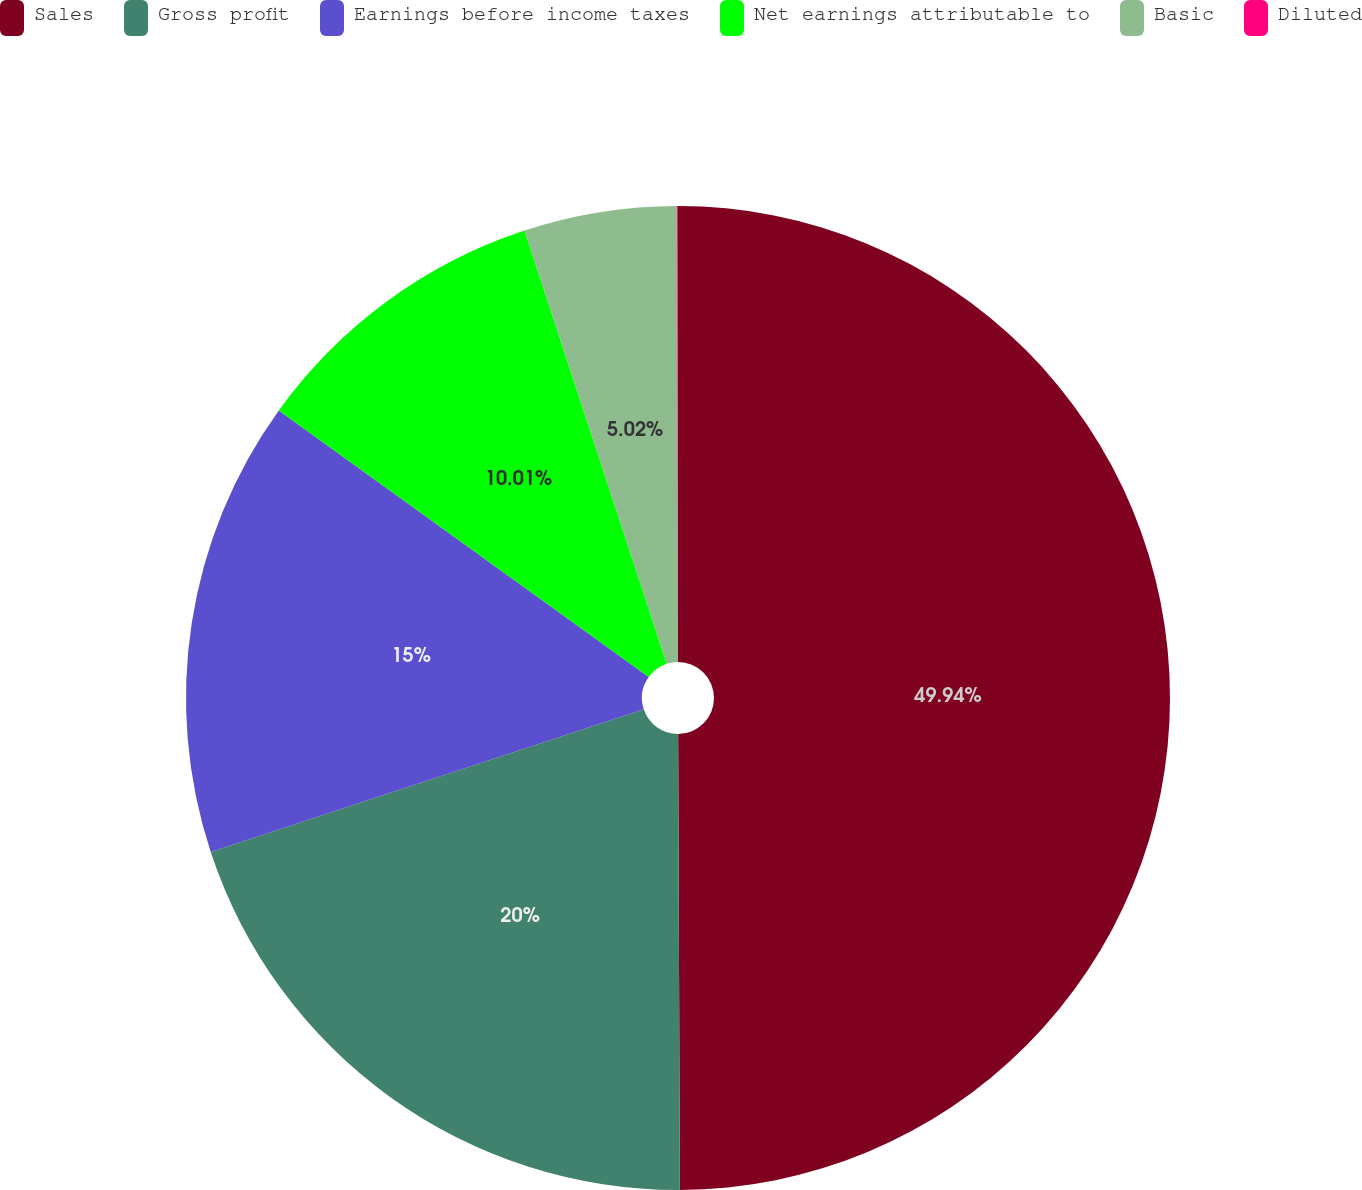Convert chart. <chart><loc_0><loc_0><loc_500><loc_500><pie_chart><fcel>Sales<fcel>Gross profit<fcel>Earnings before income taxes<fcel>Net earnings attributable to<fcel>Basic<fcel>Diluted<nl><fcel>49.93%<fcel>19.99%<fcel>15.0%<fcel>10.01%<fcel>5.02%<fcel>0.03%<nl></chart> 